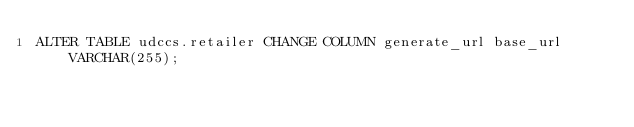Convert code to text. <code><loc_0><loc_0><loc_500><loc_500><_SQL_>ALTER TABLE udccs.retailer CHANGE COLUMN generate_url base_url VARCHAR(255);
</code> 